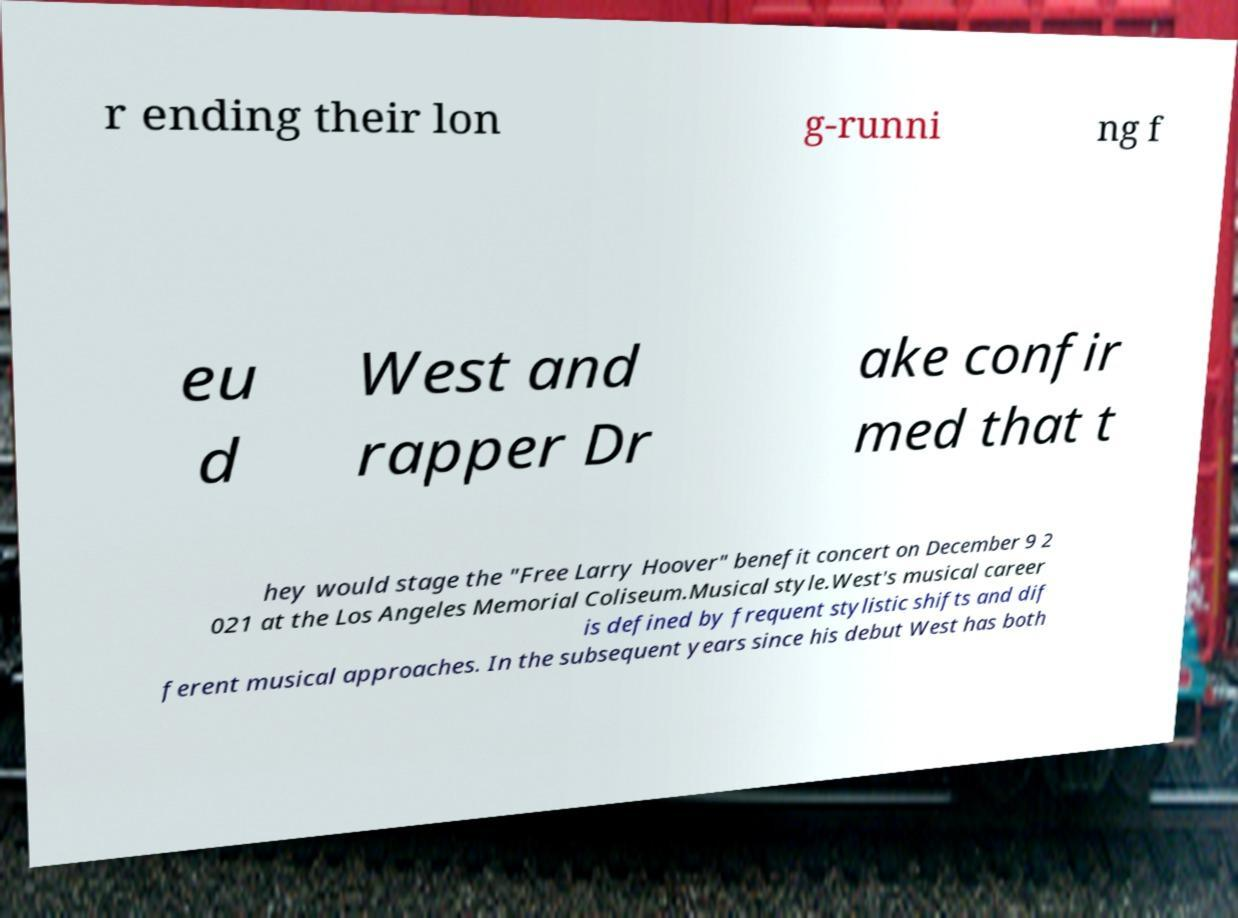Can you accurately transcribe the text from the provided image for me? r ending their lon g-runni ng f eu d West and rapper Dr ake confir med that t hey would stage the "Free Larry Hoover" benefit concert on December 9 2 021 at the Los Angeles Memorial Coliseum.Musical style.West's musical career is defined by frequent stylistic shifts and dif ferent musical approaches. In the subsequent years since his debut West has both 